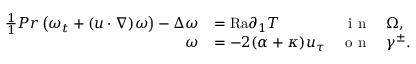<formula> <loc_0><loc_0><loc_500><loc_500>\begin{array} { r l r l } { \frac { 1 } { 1 } { P r } \left ( \omega _ { t } + ( u \cdot \nabla ) \omega \right ) - \Delta \omega } & { = { R a } \partial _ { 1 } T } & { i n } & { \Omega , } \\ { \omega } & { = - 2 ( \alpha + \kappa ) u _ { \tau } } & { o n } & { \gamma ^ { \pm } . } \end{array}</formula> 